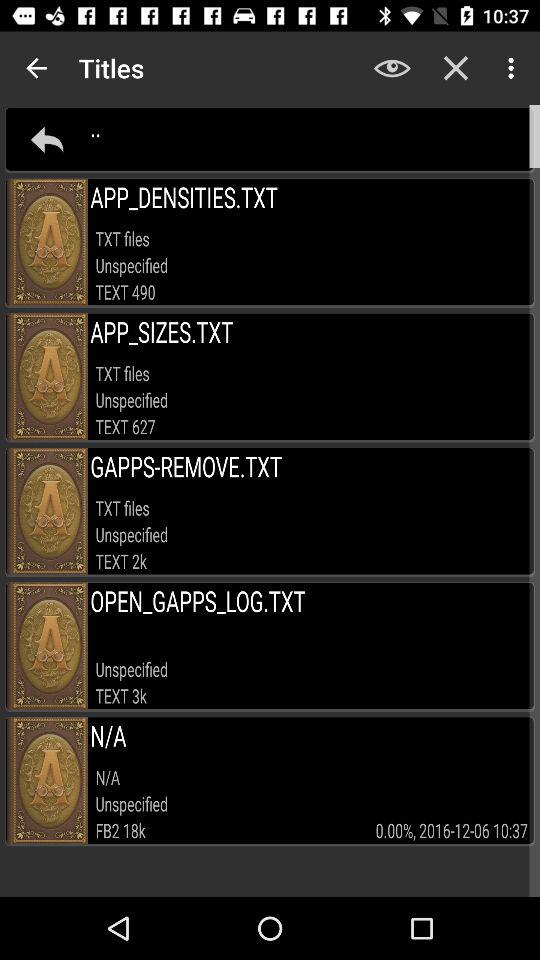What is the size of GAPPS- REMOVE.TXT?
When the provided information is insufficient, respond with <no answer>. <no answer> 